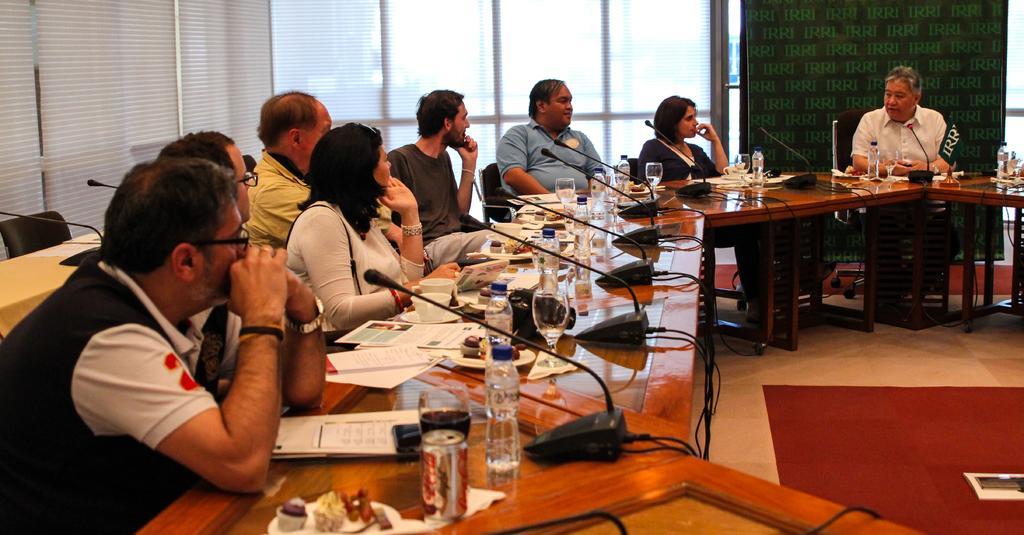Describe this image in one or two sentences. In this image, there are a few people sitting. We can see the table with some objects like microphones, glasses, bottles. We can also see the ground. We can see a board. We can also see a chair and the door blinds. 